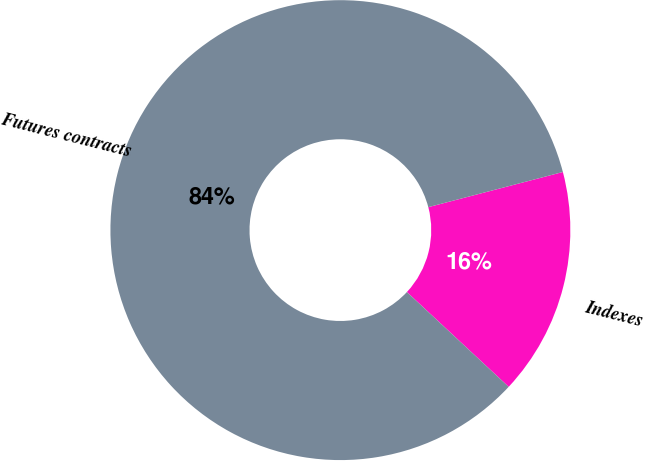Convert chart. <chart><loc_0><loc_0><loc_500><loc_500><pie_chart><fcel>Indexes<fcel>Futures contracts<nl><fcel>16.0%<fcel>84.0%<nl></chart> 